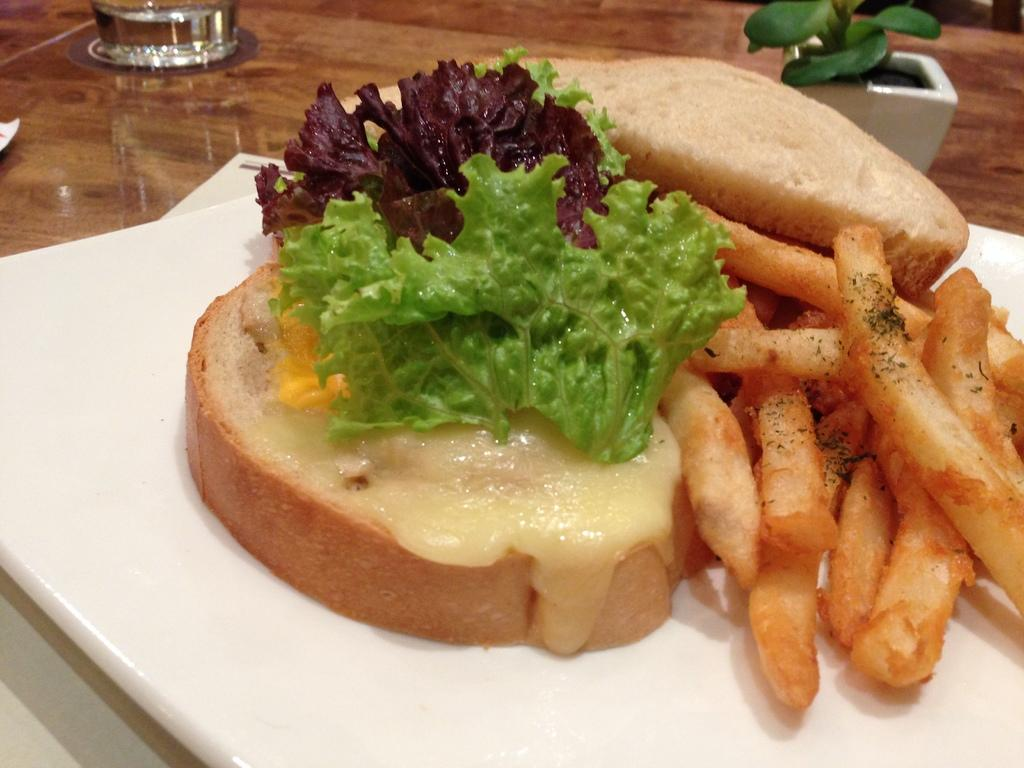What type of furniture is present in the image? There is a table in the image. What objects can be seen on the table? There are glasses, a pot with a plant, and a plate on the table. What is the plate holding? The plate contains a food item with leaves and French fries. Is there anything else on the plate? Yes, there is another unspecified item on the plate. What type of knot can be seen in the image? There is no knot present in the image. What color is the gold item in the image? There is no gold item present in the image. 